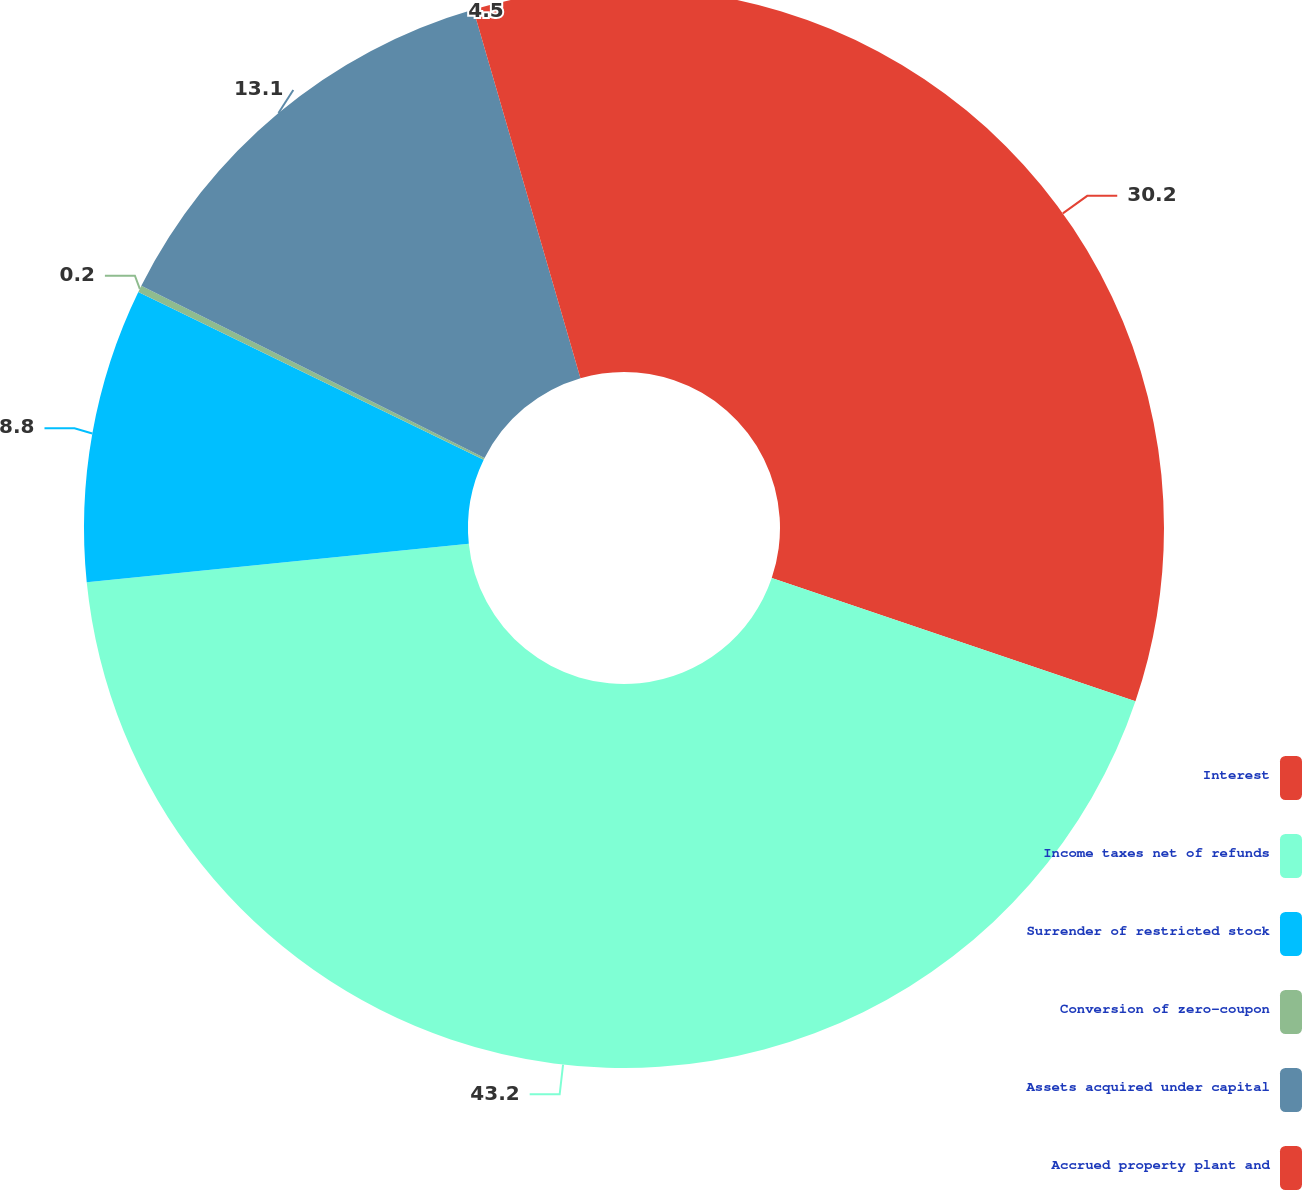Convert chart. <chart><loc_0><loc_0><loc_500><loc_500><pie_chart><fcel>Interest<fcel>Income taxes net of refunds<fcel>Surrender of restricted stock<fcel>Conversion of zero-coupon<fcel>Assets acquired under capital<fcel>Accrued property plant and<nl><fcel>30.2%<fcel>43.2%<fcel>8.8%<fcel>0.2%<fcel>13.1%<fcel>4.5%<nl></chart> 